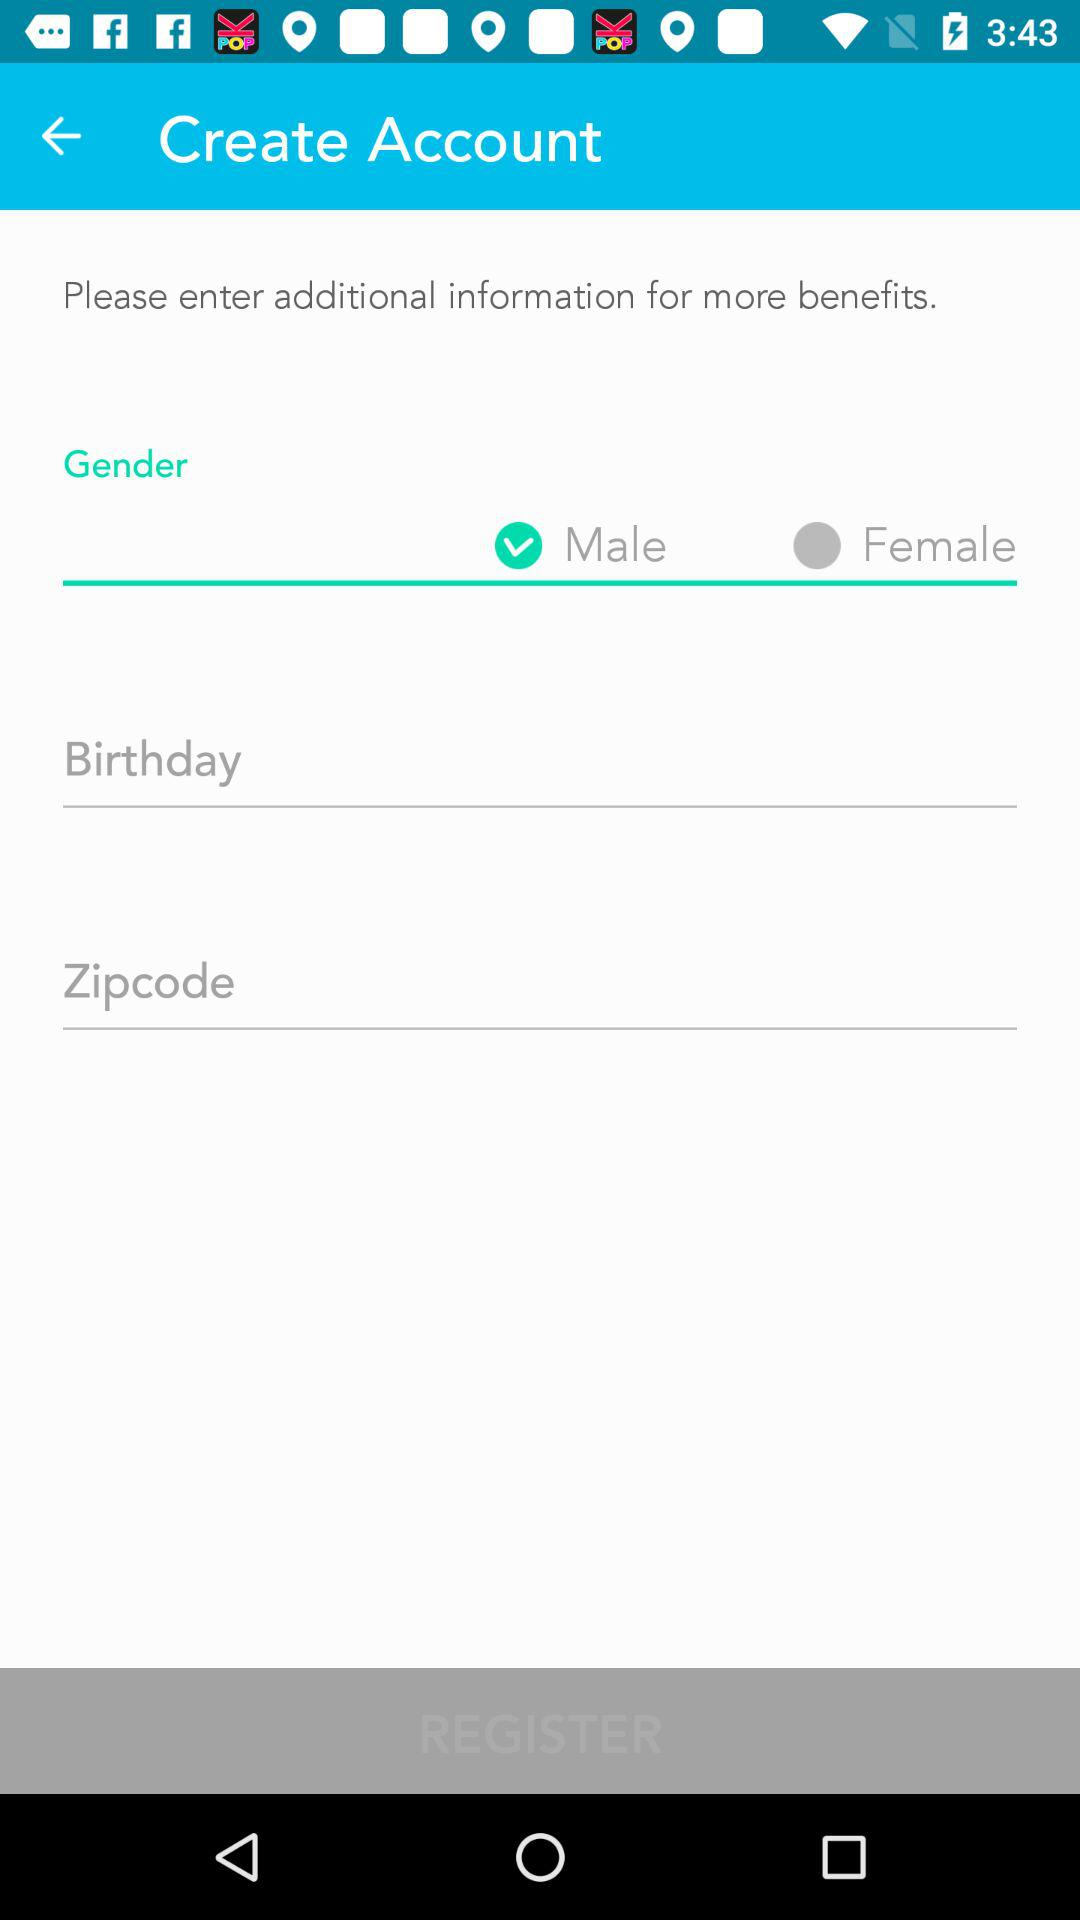Which gender has been selected? The selected gender is male. 